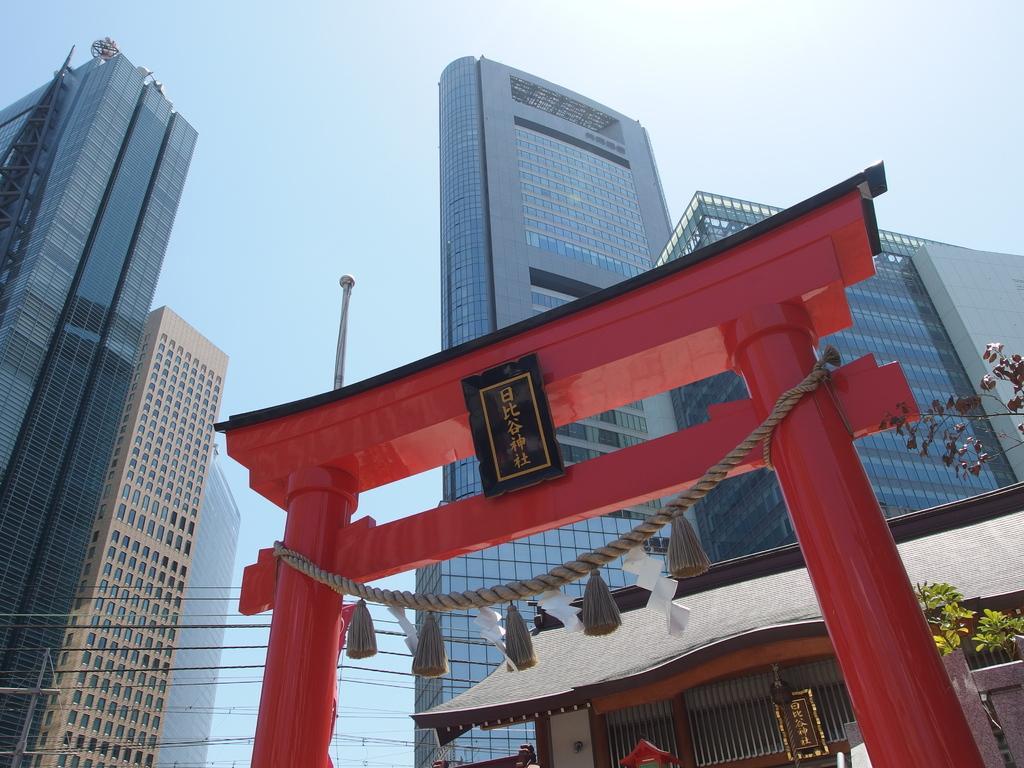In one or two sentences, can you explain what this image depicts? Here I can see an arch which is in red color. A black color board and a rope are attached to this arch. In the background, I can see many buildings. At the top of the image I can see the sky. 